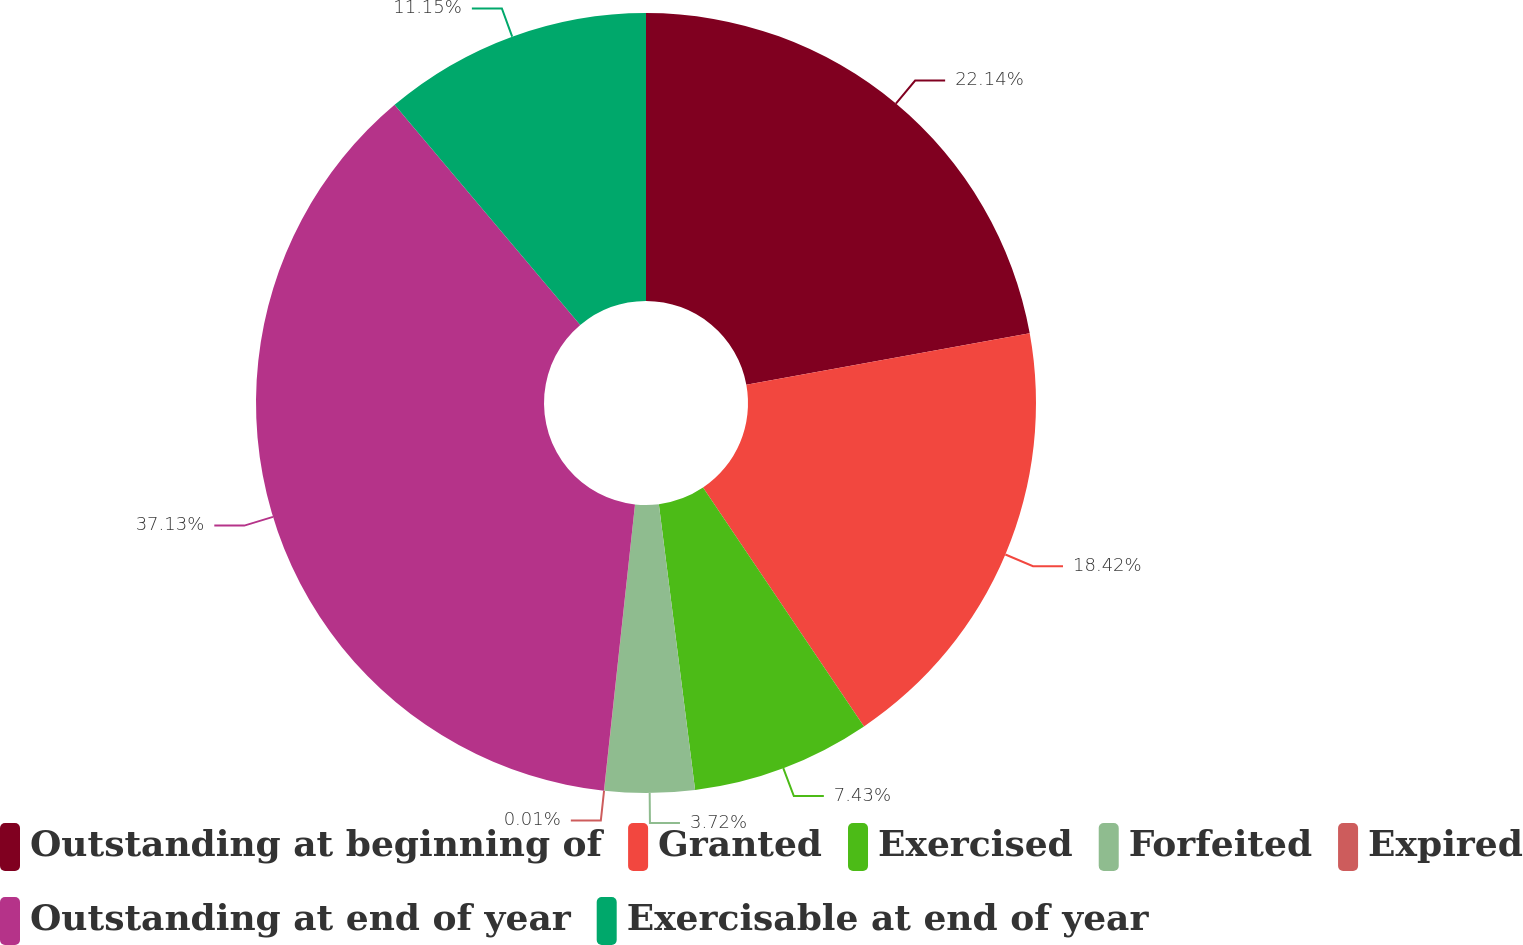Convert chart. <chart><loc_0><loc_0><loc_500><loc_500><pie_chart><fcel>Outstanding at beginning of<fcel>Granted<fcel>Exercised<fcel>Forfeited<fcel>Expired<fcel>Outstanding at end of year<fcel>Exercisable at end of year<nl><fcel>22.14%<fcel>18.42%<fcel>7.43%<fcel>3.72%<fcel>0.01%<fcel>37.13%<fcel>11.15%<nl></chart> 